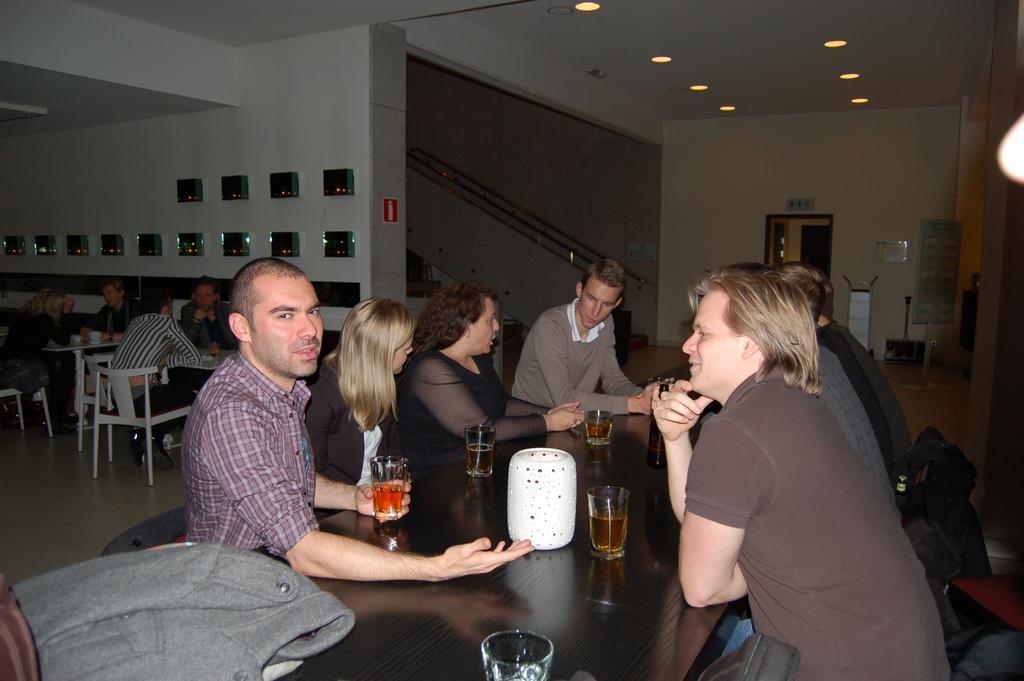How would you summarize this image in a sentence or two? In this picture we can see some persons sitting on the chairs. This is table. On the table there are glasses. On the background we can see a wall. And these are the lights. 